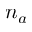<formula> <loc_0><loc_0><loc_500><loc_500>n _ { a }</formula> 